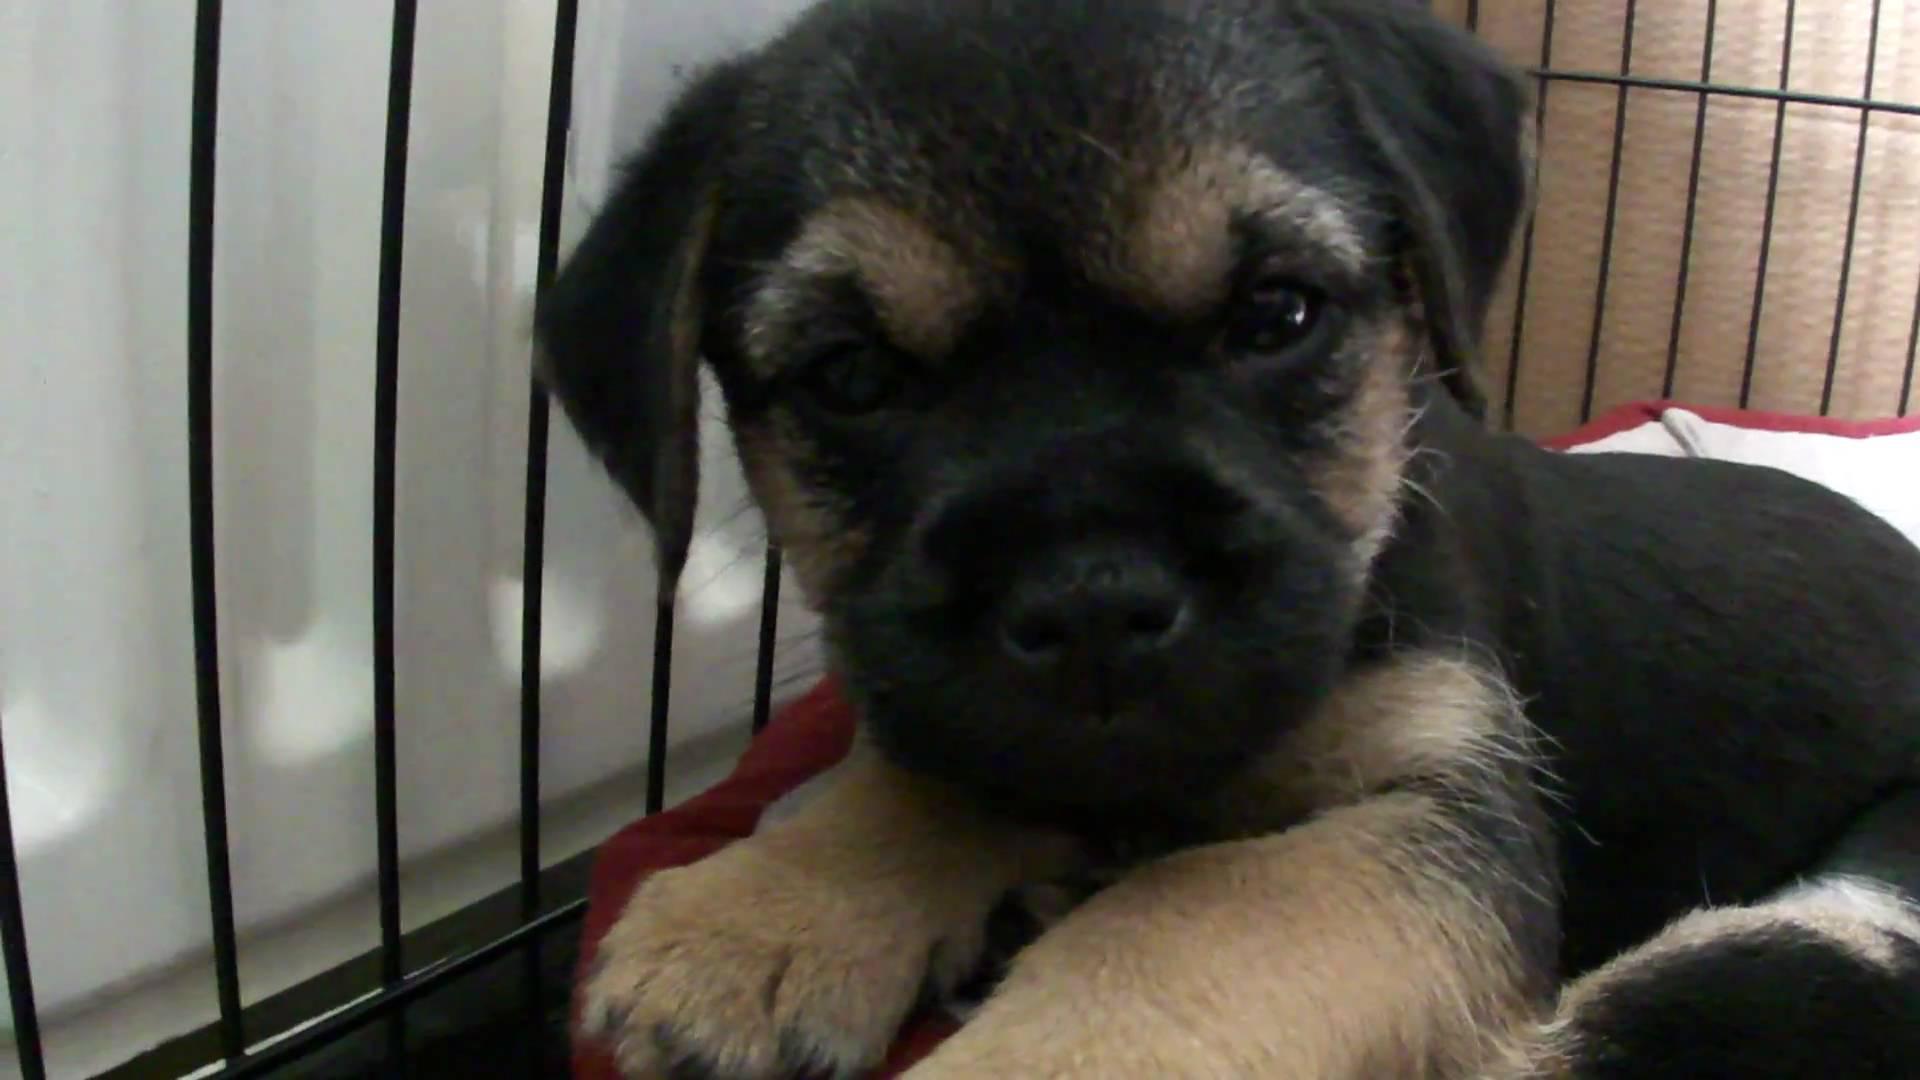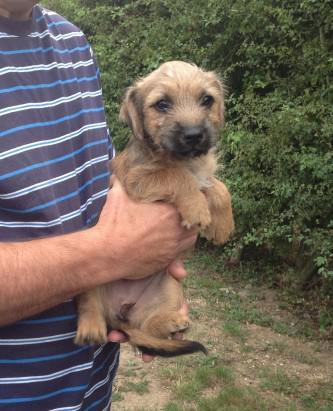The first image is the image on the left, the second image is the image on the right. Examine the images to the left and right. Is the description "In one of the two images, the dog is displaying his tongue." accurate? Answer yes or no. No. 